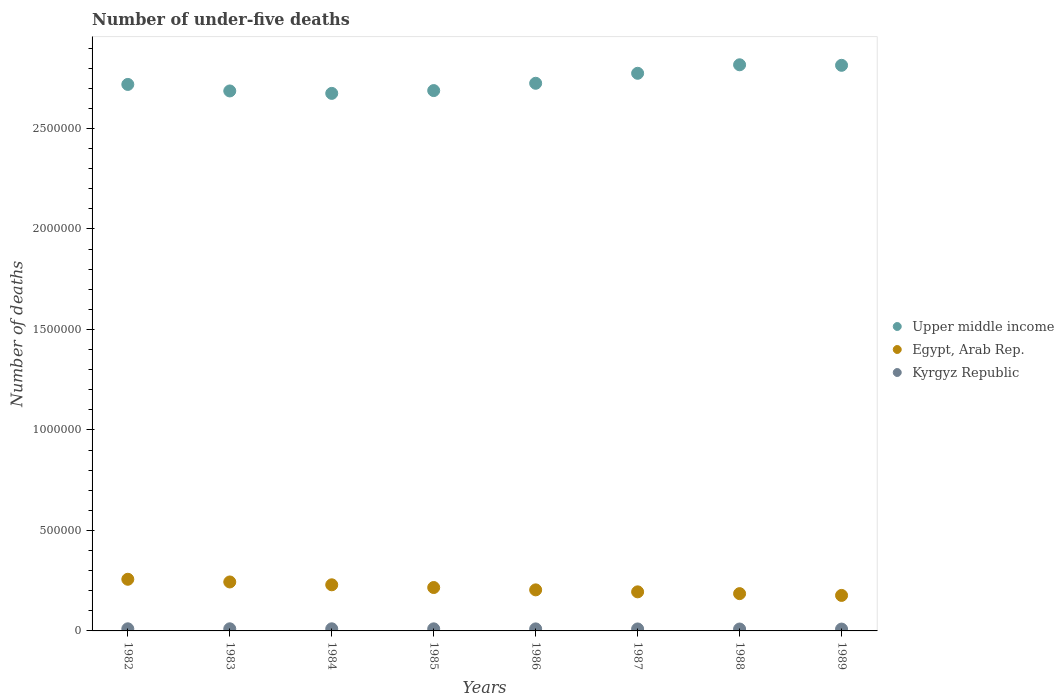How many different coloured dotlines are there?
Make the answer very short. 3. What is the number of under-five deaths in Upper middle income in 1989?
Give a very brief answer. 2.81e+06. Across all years, what is the maximum number of under-five deaths in Kyrgyz Republic?
Your response must be concise. 1.05e+04. Across all years, what is the minimum number of under-five deaths in Egypt, Arab Rep.?
Your answer should be compact. 1.77e+05. In which year was the number of under-five deaths in Egypt, Arab Rep. minimum?
Provide a short and direct response. 1989. What is the total number of under-five deaths in Kyrgyz Republic in the graph?
Keep it short and to the point. 8.05e+04. What is the difference between the number of under-five deaths in Kyrgyz Republic in 1982 and that in 1985?
Give a very brief answer. 172. What is the difference between the number of under-five deaths in Kyrgyz Republic in 1984 and the number of under-five deaths in Egypt, Arab Rep. in 1986?
Give a very brief answer. -1.94e+05. What is the average number of under-five deaths in Upper middle income per year?
Your answer should be compact. 2.74e+06. In the year 1986, what is the difference between the number of under-five deaths in Upper middle income and number of under-five deaths in Kyrgyz Republic?
Give a very brief answer. 2.71e+06. In how many years, is the number of under-five deaths in Kyrgyz Republic greater than 1000000?
Your answer should be compact. 0. What is the ratio of the number of under-five deaths in Egypt, Arab Rep. in 1983 to that in 1986?
Offer a very short reply. 1.19. Is the number of under-five deaths in Egypt, Arab Rep. in 1986 less than that in 1989?
Ensure brevity in your answer.  No. Is the difference between the number of under-five deaths in Upper middle income in 1984 and 1986 greater than the difference between the number of under-five deaths in Kyrgyz Republic in 1984 and 1986?
Your response must be concise. No. What is the difference between the highest and the second highest number of under-five deaths in Upper middle income?
Ensure brevity in your answer.  2616. What is the difference between the highest and the lowest number of under-five deaths in Kyrgyz Republic?
Your answer should be compact. 1376. In how many years, is the number of under-five deaths in Upper middle income greater than the average number of under-five deaths in Upper middle income taken over all years?
Keep it short and to the point. 3. Is the sum of the number of under-five deaths in Egypt, Arab Rep. in 1985 and 1988 greater than the maximum number of under-five deaths in Kyrgyz Republic across all years?
Make the answer very short. Yes. Is it the case that in every year, the sum of the number of under-five deaths in Upper middle income and number of under-five deaths in Kyrgyz Republic  is greater than the number of under-five deaths in Egypt, Arab Rep.?
Offer a terse response. Yes. Is the number of under-five deaths in Upper middle income strictly greater than the number of under-five deaths in Egypt, Arab Rep. over the years?
Give a very brief answer. Yes. What is the difference between two consecutive major ticks on the Y-axis?
Make the answer very short. 5.00e+05. Are the values on the major ticks of Y-axis written in scientific E-notation?
Make the answer very short. No. Does the graph contain any zero values?
Keep it short and to the point. No. Where does the legend appear in the graph?
Your answer should be very brief. Center right. How many legend labels are there?
Offer a very short reply. 3. What is the title of the graph?
Ensure brevity in your answer.  Number of under-five deaths. Does "Albania" appear as one of the legend labels in the graph?
Make the answer very short. No. What is the label or title of the X-axis?
Offer a very short reply. Years. What is the label or title of the Y-axis?
Keep it short and to the point. Number of deaths. What is the Number of deaths of Upper middle income in 1982?
Your response must be concise. 2.72e+06. What is the Number of deaths in Egypt, Arab Rep. in 1982?
Keep it short and to the point. 2.57e+05. What is the Number of deaths of Kyrgyz Republic in 1982?
Give a very brief answer. 1.05e+04. What is the Number of deaths in Upper middle income in 1983?
Give a very brief answer. 2.69e+06. What is the Number of deaths in Egypt, Arab Rep. in 1983?
Make the answer very short. 2.44e+05. What is the Number of deaths in Kyrgyz Republic in 1983?
Your answer should be very brief. 1.05e+04. What is the Number of deaths in Upper middle income in 1984?
Your answer should be very brief. 2.67e+06. What is the Number of deaths in Egypt, Arab Rep. in 1984?
Keep it short and to the point. 2.29e+05. What is the Number of deaths of Kyrgyz Republic in 1984?
Give a very brief answer. 1.05e+04. What is the Number of deaths of Upper middle income in 1985?
Your response must be concise. 2.69e+06. What is the Number of deaths of Egypt, Arab Rep. in 1985?
Provide a short and direct response. 2.16e+05. What is the Number of deaths in Kyrgyz Republic in 1985?
Offer a terse response. 1.03e+04. What is the Number of deaths of Upper middle income in 1986?
Offer a terse response. 2.72e+06. What is the Number of deaths of Egypt, Arab Rep. in 1986?
Provide a short and direct response. 2.04e+05. What is the Number of deaths in Kyrgyz Republic in 1986?
Your answer should be very brief. 1.01e+04. What is the Number of deaths of Upper middle income in 1987?
Give a very brief answer. 2.77e+06. What is the Number of deaths of Egypt, Arab Rep. in 1987?
Your answer should be compact. 1.94e+05. What is the Number of deaths of Kyrgyz Republic in 1987?
Your response must be concise. 9800. What is the Number of deaths of Upper middle income in 1988?
Provide a succinct answer. 2.82e+06. What is the Number of deaths of Egypt, Arab Rep. in 1988?
Make the answer very short. 1.86e+05. What is the Number of deaths of Kyrgyz Republic in 1988?
Ensure brevity in your answer.  9481. What is the Number of deaths of Upper middle income in 1989?
Offer a terse response. 2.81e+06. What is the Number of deaths of Egypt, Arab Rep. in 1989?
Give a very brief answer. 1.77e+05. What is the Number of deaths in Kyrgyz Republic in 1989?
Provide a short and direct response. 9173. Across all years, what is the maximum Number of deaths in Upper middle income?
Provide a short and direct response. 2.82e+06. Across all years, what is the maximum Number of deaths of Egypt, Arab Rep.?
Provide a succinct answer. 2.57e+05. Across all years, what is the maximum Number of deaths of Kyrgyz Republic?
Keep it short and to the point. 1.05e+04. Across all years, what is the minimum Number of deaths of Upper middle income?
Make the answer very short. 2.67e+06. Across all years, what is the minimum Number of deaths of Egypt, Arab Rep.?
Keep it short and to the point. 1.77e+05. Across all years, what is the minimum Number of deaths in Kyrgyz Republic?
Your response must be concise. 9173. What is the total Number of deaths in Upper middle income in the graph?
Offer a very short reply. 2.19e+07. What is the total Number of deaths in Egypt, Arab Rep. in the graph?
Keep it short and to the point. 1.71e+06. What is the total Number of deaths of Kyrgyz Republic in the graph?
Your answer should be compact. 8.05e+04. What is the difference between the Number of deaths in Upper middle income in 1982 and that in 1983?
Your answer should be very brief. 3.25e+04. What is the difference between the Number of deaths in Egypt, Arab Rep. in 1982 and that in 1983?
Make the answer very short. 1.34e+04. What is the difference between the Number of deaths in Kyrgyz Republic in 1982 and that in 1983?
Your answer should be very brief. -41. What is the difference between the Number of deaths in Upper middle income in 1982 and that in 1984?
Ensure brevity in your answer.  4.45e+04. What is the difference between the Number of deaths of Egypt, Arab Rep. in 1982 and that in 1984?
Your answer should be very brief. 2.75e+04. What is the difference between the Number of deaths in Upper middle income in 1982 and that in 1985?
Provide a short and direct response. 3.06e+04. What is the difference between the Number of deaths of Egypt, Arab Rep. in 1982 and that in 1985?
Offer a very short reply. 4.11e+04. What is the difference between the Number of deaths of Kyrgyz Republic in 1982 and that in 1985?
Your response must be concise. 172. What is the difference between the Number of deaths in Upper middle income in 1982 and that in 1986?
Offer a terse response. -5718. What is the difference between the Number of deaths in Egypt, Arab Rep. in 1982 and that in 1986?
Ensure brevity in your answer.  5.27e+04. What is the difference between the Number of deaths in Kyrgyz Republic in 1982 and that in 1986?
Provide a short and direct response. 415. What is the difference between the Number of deaths of Upper middle income in 1982 and that in 1987?
Keep it short and to the point. -5.54e+04. What is the difference between the Number of deaths of Egypt, Arab Rep. in 1982 and that in 1987?
Keep it short and to the point. 6.26e+04. What is the difference between the Number of deaths in Kyrgyz Republic in 1982 and that in 1987?
Give a very brief answer. 708. What is the difference between the Number of deaths of Upper middle income in 1982 and that in 1988?
Provide a succinct answer. -9.77e+04. What is the difference between the Number of deaths of Egypt, Arab Rep. in 1982 and that in 1988?
Make the answer very short. 7.15e+04. What is the difference between the Number of deaths of Kyrgyz Republic in 1982 and that in 1988?
Your answer should be very brief. 1027. What is the difference between the Number of deaths in Upper middle income in 1982 and that in 1989?
Your response must be concise. -9.51e+04. What is the difference between the Number of deaths in Egypt, Arab Rep. in 1982 and that in 1989?
Ensure brevity in your answer.  8.03e+04. What is the difference between the Number of deaths in Kyrgyz Republic in 1982 and that in 1989?
Make the answer very short. 1335. What is the difference between the Number of deaths of Upper middle income in 1983 and that in 1984?
Offer a very short reply. 1.21e+04. What is the difference between the Number of deaths in Egypt, Arab Rep. in 1983 and that in 1984?
Keep it short and to the point. 1.42e+04. What is the difference between the Number of deaths of Upper middle income in 1983 and that in 1985?
Make the answer very short. -1835. What is the difference between the Number of deaths in Egypt, Arab Rep. in 1983 and that in 1985?
Make the answer very short. 2.77e+04. What is the difference between the Number of deaths of Kyrgyz Republic in 1983 and that in 1985?
Your answer should be very brief. 213. What is the difference between the Number of deaths of Upper middle income in 1983 and that in 1986?
Provide a short and direct response. -3.82e+04. What is the difference between the Number of deaths in Egypt, Arab Rep. in 1983 and that in 1986?
Keep it short and to the point. 3.93e+04. What is the difference between the Number of deaths in Kyrgyz Republic in 1983 and that in 1986?
Keep it short and to the point. 456. What is the difference between the Number of deaths in Upper middle income in 1983 and that in 1987?
Your answer should be compact. -8.79e+04. What is the difference between the Number of deaths of Egypt, Arab Rep. in 1983 and that in 1987?
Offer a terse response. 4.92e+04. What is the difference between the Number of deaths in Kyrgyz Republic in 1983 and that in 1987?
Provide a succinct answer. 749. What is the difference between the Number of deaths of Upper middle income in 1983 and that in 1988?
Keep it short and to the point. -1.30e+05. What is the difference between the Number of deaths in Egypt, Arab Rep. in 1983 and that in 1988?
Offer a very short reply. 5.81e+04. What is the difference between the Number of deaths of Kyrgyz Republic in 1983 and that in 1988?
Offer a terse response. 1068. What is the difference between the Number of deaths of Upper middle income in 1983 and that in 1989?
Offer a very short reply. -1.28e+05. What is the difference between the Number of deaths in Egypt, Arab Rep. in 1983 and that in 1989?
Ensure brevity in your answer.  6.69e+04. What is the difference between the Number of deaths in Kyrgyz Republic in 1983 and that in 1989?
Offer a very short reply. 1376. What is the difference between the Number of deaths in Upper middle income in 1984 and that in 1985?
Make the answer very short. -1.39e+04. What is the difference between the Number of deaths of Egypt, Arab Rep. in 1984 and that in 1985?
Give a very brief answer. 1.36e+04. What is the difference between the Number of deaths in Kyrgyz Republic in 1984 and that in 1985?
Your answer should be compact. 177. What is the difference between the Number of deaths of Upper middle income in 1984 and that in 1986?
Give a very brief answer. -5.03e+04. What is the difference between the Number of deaths in Egypt, Arab Rep. in 1984 and that in 1986?
Give a very brief answer. 2.52e+04. What is the difference between the Number of deaths in Kyrgyz Republic in 1984 and that in 1986?
Provide a succinct answer. 420. What is the difference between the Number of deaths in Upper middle income in 1984 and that in 1987?
Provide a succinct answer. -9.99e+04. What is the difference between the Number of deaths in Egypt, Arab Rep. in 1984 and that in 1987?
Offer a very short reply. 3.51e+04. What is the difference between the Number of deaths of Kyrgyz Republic in 1984 and that in 1987?
Make the answer very short. 713. What is the difference between the Number of deaths of Upper middle income in 1984 and that in 1988?
Offer a terse response. -1.42e+05. What is the difference between the Number of deaths in Egypt, Arab Rep. in 1984 and that in 1988?
Your answer should be compact. 4.39e+04. What is the difference between the Number of deaths of Kyrgyz Republic in 1984 and that in 1988?
Your answer should be compact. 1032. What is the difference between the Number of deaths in Upper middle income in 1984 and that in 1989?
Give a very brief answer. -1.40e+05. What is the difference between the Number of deaths in Egypt, Arab Rep. in 1984 and that in 1989?
Give a very brief answer. 5.28e+04. What is the difference between the Number of deaths in Kyrgyz Republic in 1984 and that in 1989?
Your answer should be very brief. 1340. What is the difference between the Number of deaths of Upper middle income in 1985 and that in 1986?
Keep it short and to the point. -3.64e+04. What is the difference between the Number of deaths in Egypt, Arab Rep. in 1985 and that in 1986?
Provide a short and direct response. 1.16e+04. What is the difference between the Number of deaths in Kyrgyz Republic in 1985 and that in 1986?
Offer a terse response. 243. What is the difference between the Number of deaths in Upper middle income in 1985 and that in 1987?
Offer a terse response. -8.60e+04. What is the difference between the Number of deaths in Egypt, Arab Rep. in 1985 and that in 1987?
Make the answer very short. 2.15e+04. What is the difference between the Number of deaths of Kyrgyz Republic in 1985 and that in 1987?
Provide a succinct answer. 536. What is the difference between the Number of deaths in Upper middle income in 1985 and that in 1988?
Your answer should be very brief. -1.28e+05. What is the difference between the Number of deaths of Egypt, Arab Rep. in 1985 and that in 1988?
Provide a succinct answer. 3.04e+04. What is the difference between the Number of deaths in Kyrgyz Republic in 1985 and that in 1988?
Keep it short and to the point. 855. What is the difference between the Number of deaths in Upper middle income in 1985 and that in 1989?
Give a very brief answer. -1.26e+05. What is the difference between the Number of deaths of Egypt, Arab Rep. in 1985 and that in 1989?
Provide a short and direct response. 3.92e+04. What is the difference between the Number of deaths in Kyrgyz Republic in 1985 and that in 1989?
Make the answer very short. 1163. What is the difference between the Number of deaths in Upper middle income in 1986 and that in 1987?
Ensure brevity in your answer.  -4.97e+04. What is the difference between the Number of deaths of Egypt, Arab Rep. in 1986 and that in 1987?
Offer a terse response. 9883. What is the difference between the Number of deaths in Kyrgyz Republic in 1986 and that in 1987?
Give a very brief answer. 293. What is the difference between the Number of deaths in Upper middle income in 1986 and that in 1988?
Offer a very short reply. -9.20e+04. What is the difference between the Number of deaths in Egypt, Arab Rep. in 1986 and that in 1988?
Give a very brief answer. 1.88e+04. What is the difference between the Number of deaths of Kyrgyz Republic in 1986 and that in 1988?
Your response must be concise. 612. What is the difference between the Number of deaths in Upper middle income in 1986 and that in 1989?
Offer a very short reply. -8.94e+04. What is the difference between the Number of deaths in Egypt, Arab Rep. in 1986 and that in 1989?
Your response must be concise. 2.76e+04. What is the difference between the Number of deaths in Kyrgyz Republic in 1986 and that in 1989?
Provide a short and direct response. 920. What is the difference between the Number of deaths of Upper middle income in 1987 and that in 1988?
Your answer should be compact. -4.23e+04. What is the difference between the Number of deaths of Egypt, Arab Rep. in 1987 and that in 1988?
Keep it short and to the point. 8878. What is the difference between the Number of deaths of Kyrgyz Republic in 1987 and that in 1988?
Give a very brief answer. 319. What is the difference between the Number of deaths of Upper middle income in 1987 and that in 1989?
Your answer should be very brief. -3.97e+04. What is the difference between the Number of deaths of Egypt, Arab Rep. in 1987 and that in 1989?
Ensure brevity in your answer.  1.77e+04. What is the difference between the Number of deaths of Kyrgyz Republic in 1987 and that in 1989?
Ensure brevity in your answer.  627. What is the difference between the Number of deaths in Upper middle income in 1988 and that in 1989?
Provide a succinct answer. 2616. What is the difference between the Number of deaths in Egypt, Arab Rep. in 1988 and that in 1989?
Your answer should be compact. 8860. What is the difference between the Number of deaths of Kyrgyz Republic in 1988 and that in 1989?
Your answer should be compact. 308. What is the difference between the Number of deaths of Upper middle income in 1982 and the Number of deaths of Egypt, Arab Rep. in 1983?
Provide a succinct answer. 2.48e+06. What is the difference between the Number of deaths in Upper middle income in 1982 and the Number of deaths in Kyrgyz Republic in 1983?
Offer a very short reply. 2.71e+06. What is the difference between the Number of deaths of Egypt, Arab Rep. in 1982 and the Number of deaths of Kyrgyz Republic in 1983?
Offer a very short reply. 2.46e+05. What is the difference between the Number of deaths of Upper middle income in 1982 and the Number of deaths of Egypt, Arab Rep. in 1984?
Your response must be concise. 2.49e+06. What is the difference between the Number of deaths in Upper middle income in 1982 and the Number of deaths in Kyrgyz Republic in 1984?
Your response must be concise. 2.71e+06. What is the difference between the Number of deaths in Egypt, Arab Rep. in 1982 and the Number of deaths in Kyrgyz Republic in 1984?
Offer a terse response. 2.46e+05. What is the difference between the Number of deaths of Upper middle income in 1982 and the Number of deaths of Egypt, Arab Rep. in 1985?
Provide a succinct answer. 2.50e+06. What is the difference between the Number of deaths of Upper middle income in 1982 and the Number of deaths of Kyrgyz Republic in 1985?
Your answer should be compact. 2.71e+06. What is the difference between the Number of deaths in Egypt, Arab Rep. in 1982 and the Number of deaths in Kyrgyz Republic in 1985?
Ensure brevity in your answer.  2.47e+05. What is the difference between the Number of deaths in Upper middle income in 1982 and the Number of deaths in Egypt, Arab Rep. in 1986?
Offer a very short reply. 2.51e+06. What is the difference between the Number of deaths in Upper middle income in 1982 and the Number of deaths in Kyrgyz Republic in 1986?
Your answer should be compact. 2.71e+06. What is the difference between the Number of deaths of Egypt, Arab Rep. in 1982 and the Number of deaths of Kyrgyz Republic in 1986?
Offer a terse response. 2.47e+05. What is the difference between the Number of deaths of Upper middle income in 1982 and the Number of deaths of Egypt, Arab Rep. in 1987?
Your answer should be very brief. 2.52e+06. What is the difference between the Number of deaths in Upper middle income in 1982 and the Number of deaths in Kyrgyz Republic in 1987?
Offer a terse response. 2.71e+06. What is the difference between the Number of deaths in Egypt, Arab Rep. in 1982 and the Number of deaths in Kyrgyz Republic in 1987?
Keep it short and to the point. 2.47e+05. What is the difference between the Number of deaths in Upper middle income in 1982 and the Number of deaths in Egypt, Arab Rep. in 1988?
Your response must be concise. 2.53e+06. What is the difference between the Number of deaths in Upper middle income in 1982 and the Number of deaths in Kyrgyz Republic in 1988?
Offer a terse response. 2.71e+06. What is the difference between the Number of deaths in Egypt, Arab Rep. in 1982 and the Number of deaths in Kyrgyz Republic in 1988?
Give a very brief answer. 2.48e+05. What is the difference between the Number of deaths of Upper middle income in 1982 and the Number of deaths of Egypt, Arab Rep. in 1989?
Your answer should be compact. 2.54e+06. What is the difference between the Number of deaths in Upper middle income in 1982 and the Number of deaths in Kyrgyz Republic in 1989?
Your answer should be compact. 2.71e+06. What is the difference between the Number of deaths in Egypt, Arab Rep. in 1982 and the Number of deaths in Kyrgyz Republic in 1989?
Your answer should be compact. 2.48e+05. What is the difference between the Number of deaths in Upper middle income in 1983 and the Number of deaths in Egypt, Arab Rep. in 1984?
Offer a very short reply. 2.46e+06. What is the difference between the Number of deaths of Upper middle income in 1983 and the Number of deaths of Kyrgyz Republic in 1984?
Make the answer very short. 2.68e+06. What is the difference between the Number of deaths in Egypt, Arab Rep. in 1983 and the Number of deaths in Kyrgyz Republic in 1984?
Offer a very short reply. 2.33e+05. What is the difference between the Number of deaths in Upper middle income in 1983 and the Number of deaths in Egypt, Arab Rep. in 1985?
Offer a terse response. 2.47e+06. What is the difference between the Number of deaths in Upper middle income in 1983 and the Number of deaths in Kyrgyz Republic in 1985?
Provide a succinct answer. 2.68e+06. What is the difference between the Number of deaths in Egypt, Arab Rep. in 1983 and the Number of deaths in Kyrgyz Republic in 1985?
Make the answer very short. 2.33e+05. What is the difference between the Number of deaths in Upper middle income in 1983 and the Number of deaths in Egypt, Arab Rep. in 1986?
Your response must be concise. 2.48e+06. What is the difference between the Number of deaths in Upper middle income in 1983 and the Number of deaths in Kyrgyz Republic in 1986?
Your response must be concise. 2.68e+06. What is the difference between the Number of deaths of Egypt, Arab Rep. in 1983 and the Number of deaths of Kyrgyz Republic in 1986?
Your response must be concise. 2.34e+05. What is the difference between the Number of deaths in Upper middle income in 1983 and the Number of deaths in Egypt, Arab Rep. in 1987?
Keep it short and to the point. 2.49e+06. What is the difference between the Number of deaths of Upper middle income in 1983 and the Number of deaths of Kyrgyz Republic in 1987?
Your response must be concise. 2.68e+06. What is the difference between the Number of deaths of Egypt, Arab Rep. in 1983 and the Number of deaths of Kyrgyz Republic in 1987?
Keep it short and to the point. 2.34e+05. What is the difference between the Number of deaths in Upper middle income in 1983 and the Number of deaths in Egypt, Arab Rep. in 1988?
Provide a short and direct response. 2.50e+06. What is the difference between the Number of deaths of Upper middle income in 1983 and the Number of deaths of Kyrgyz Republic in 1988?
Offer a terse response. 2.68e+06. What is the difference between the Number of deaths in Egypt, Arab Rep. in 1983 and the Number of deaths in Kyrgyz Republic in 1988?
Ensure brevity in your answer.  2.34e+05. What is the difference between the Number of deaths of Upper middle income in 1983 and the Number of deaths of Egypt, Arab Rep. in 1989?
Ensure brevity in your answer.  2.51e+06. What is the difference between the Number of deaths of Upper middle income in 1983 and the Number of deaths of Kyrgyz Republic in 1989?
Your response must be concise. 2.68e+06. What is the difference between the Number of deaths in Egypt, Arab Rep. in 1983 and the Number of deaths in Kyrgyz Republic in 1989?
Make the answer very short. 2.34e+05. What is the difference between the Number of deaths of Upper middle income in 1984 and the Number of deaths of Egypt, Arab Rep. in 1985?
Offer a terse response. 2.46e+06. What is the difference between the Number of deaths in Upper middle income in 1984 and the Number of deaths in Kyrgyz Republic in 1985?
Provide a succinct answer. 2.66e+06. What is the difference between the Number of deaths of Egypt, Arab Rep. in 1984 and the Number of deaths of Kyrgyz Republic in 1985?
Your response must be concise. 2.19e+05. What is the difference between the Number of deaths of Upper middle income in 1984 and the Number of deaths of Egypt, Arab Rep. in 1986?
Offer a very short reply. 2.47e+06. What is the difference between the Number of deaths of Upper middle income in 1984 and the Number of deaths of Kyrgyz Republic in 1986?
Offer a very short reply. 2.66e+06. What is the difference between the Number of deaths of Egypt, Arab Rep. in 1984 and the Number of deaths of Kyrgyz Republic in 1986?
Give a very brief answer. 2.19e+05. What is the difference between the Number of deaths in Upper middle income in 1984 and the Number of deaths in Egypt, Arab Rep. in 1987?
Offer a terse response. 2.48e+06. What is the difference between the Number of deaths in Upper middle income in 1984 and the Number of deaths in Kyrgyz Republic in 1987?
Offer a terse response. 2.66e+06. What is the difference between the Number of deaths of Egypt, Arab Rep. in 1984 and the Number of deaths of Kyrgyz Republic in 1987?
Provide a succinct answer. 2.20e+05. What is the difference between the Number of deaths in Upper middle income in 1984 and the Number of deaths in Egypt, Arab Rep. in 1988?
Your answer should be very brief. 2.49e+06. What is the difference between the Number of deaths in Upper middle income in 1984 and the Number of deaths in Kyrgyz Republic in 1988?
Offer a terse response. 2.66e+06. What is the difference between the Number of deaths of Egypt, Arab Rep. in 1984 and the Number of deaths of Kyrgyz Republic in 1988?
Offer a terse response. 2.20e+05. What is the difference between the Number of deaths in Upper middle income in 1984 and the Number of deaths in Egypt, Arab Rep. in 1989?
Make the answer very short. 2.50e+06. What is the difference between the Number of deaths in Upper middle income in 1984 and the Number of deaths in Kyrgyz Republic in 1989?
Provide a succinct answer. 2.67e+06. What is the difference between the Number of deaths of Egypt, Arab Rep. in 1984 and the Number of deaths of Kyrgyz Republic in 1989?
Ensure brevity in your answer.  2.20e+05. What is the difference between the Number of deaths of Upper middle income in 1985 and the Number of deaths of Egypt, Arab Rep. in 1986?
Provide a succinct answer. 2.48e+06. What is the difference between the Number of deaths in Upper middle income in 1985 and the Number of deaths in Kyrgyz Republic in 1986?
Keep it short and to the point. 2.68e+06. What is the difference between the Number of deaths in Egypt, Arab Rep. in 1985 and the Number of deaths in Kyrgyz Republic in 1986?
Ensure brevity in your answer.  2.06e+05. What is the difference between the Number of deaths of Upper middle income in 1985 and the Number of deaths of Egypt, Arab Rep. in 1987?
Ensure brevity in your answer.  2.49e+06. What is the difference between the Number of deaths of Upper middle income in 1985 and the Number of deaths of Kyrgyz Republic in 1987?
Provide a short and direct response. 2.68e+06. What is the difference between the Number of deaths of Egypt, Arab Rep. in 1985 and the Number of deaths of Kyrgyz Republic in 1987?
Make the answer very short. 2.06e+05. What is the difference between the Number of deaths of Upper middle income in 1985 and the Number of deaths of Egypt, Arab Rep. in 1988?
Offer a very short reply. 2.50e+06. What is the difference between the Number of deaths in Upper middle income in 1985 and the Number of deaths in Kyrgyz Republic in 1988?
Provide a succinct answer. 2.68e+06. What is the difference between the Number of deaths of Egypt, Arab Rep. in 1985 and the Number of deaths of Kyrgyz Republic in 1988?
Keep it short and to the point. 2.06e+05. What is the difference between the Number of deaths in Upper middle income in 1985 and the Number of deaths in Egypt, Arab Rep. in 1989?
Your response must be concise. 2.51e+06. What is the difference between the Number of deaths of Upper middle income in 1985 and the Number of deaths of Kyrgyz Republic in 1989?
Your response must be concise. 2.68e+06. What is the difference between the Number of deaths in Egypt, Arab Rep. in 1985 and the Number of deaths in Kyrgyz Republic in 1989?
Provide a short and direct response. 2.07e+05. What is the difference between the Number of deaths in Upper middle income in 1986 and the Number of deaths in Egypt, Arab Rep. in 1987?
Make the answer very short. 2.53e+06. What is the difference between the Number of deaths in Upper middle income in 1986 and the Number of deaths in Kyrgyz Republic in 1987?
Your response must be concise. 2.71e+06. What is the difference between the Number of deaths of Egypt, Arab Rep. in 1986 and the Number of deaths of Kyrgyz Republic in 1987?
Offer a very short reply. 1.94e+05. What is the difference between the Number of deaths of Upper middle income in 1986 and the Number of deaths of Egypt, Arab Rep. in 1988?
Give a very brief answer. 2.54e+06. What is the difference between the Number of deaths in Upper middle income in 1986 and the Number of deaths in Kyrgyz Republic in 1988?
Provide a short and direct response. 2.72e+06. What is the difference between the Number of deaths of Egypt, Arab Rep. in 1986 and the Number of deaths of Kyrgyz Republic in 1988?
Give a very brief answer. 1.95e+05. What is the difference between the Number of deaths in Upper middle income in 1986 and the Number of deaths in Egypt, Arab Rep. in 1989?
Offer a very short reply. 2.55e+06. What is the difference between the Number of deaths in Upper middle income in 1986 and the Number of deaths in Kyrgyz Republic in 1989?
Make the answer very short. 2.72e+06. What is the difference between the Number of deaths of Egypt, Arab Rep. in 1986 and the Number of deaths of Kyrgyz Republic in 1989?
Ensure brevity in your answer.  1.95e+05. What is the difference between the Number of deaths of Upper middle income in 1987 and the Number of deaths of Egypt, Arab Rep. in 1988?
Keep it short and to the point. 2.59e+06. What is the difference between the Number of deaths in Upper middle income in 1987 and the Number of deaths in Kyrgyz Republic in 1988?
Provide a succinct answer. 2.76e+06. What is the difference between the Number of deaths of Egypt, Arab Rep. in 1987 and the Number of deaths of Kyrgyz Republic in 1988?
Your answer should be very brief. 1.85e+05. What is the difference between the Number of deaths of Upper middle income in 1987 and the Number of deaths of Egypt, Arab Rep. in 1989?
Your response must be concise. 2.60e+06. What is the difference between the Number of deaths in Upper middle income in 1987 and the Number of deaths in Kyrgyz Republic in 1989?
Ensure brevity in your answer.  2.77e+06. What is the difference between the Number of deaths of Egypt, Arab Rep. in 1987 and the Number of deaths of Kyrgyz Republic in 1989?
Ensure brevity in your answer.  1.85e+05. What is the difference between the Number of deaths in Upper middle income in 1988 and the Number of deaths in Egypt, Arab Rep. in 1989?
Offer a terse response. 2.64e+06. What is the difference between the Number of deaths of Upper middle income in 1988 and the Number of deaths of Kyrgyz Republic in 1989?
Keep it short and to the point. 2.81e+06. What is the difference between the Number of deaths in Egypt, Arab Rep. in 1988 and the Number of deaths in Kyrgyz Republic in 1989?
Offer a very short reply. 1.76e+05. What is the average Number of deaths of Upper middle income per year?
Offer a terse response. 2.74e+06. What is the average Number of deaths in Egypt, Arab Rep. per year?
Ensure brevity in your answer.  2.13e+05. What is the average Number of deaths in Kyrgyz Republic per year?
Keep it short and to the point. 1.01e+04. In the year 1982, what is the difference between the Number of deaths in Upper middle income and Number of deaths in Egypt, Arab Rep.?
Your answer should be very brief. 2.46e+06. In the year 1982, what is the difference between the Number of deaths of Upper middle income and Number of deaths of Kyrgyz Republic?
Offer a very short reply. 2.71e+06. In the year 1982, what is the difference between the Number of deaths of Egypt, Arab Rep. and Number of deaths of Kyrgyz Republic?
Offer a very short reply. 2.46e+05. In the year 1983, what is the difference between the Number of deaths of Upper middle income and Number of deaths of Egypt, Arab Rep.?
Give a very brief answer. 2.44e+06. In the year 1983, what is the difference between the Number of deaths in Upper middle income and Number of deaths in Kyrgyz Republic?
Your response must be concise. 2.68e+06. In the year 1983, what is the difference between the Number of deaths in Egypt, Arab Rep. and Number of deaths in Kyrgyz Republic?
Your answer should be very brief. 2.33e+05. In the year 1984, what is the difference between the Number of deaths in Upper middle income and Number of deaths in Egypt, Arab Rep.?
Offer a very short reply. 2.44e+06. In the year 1984, what is the difference between the Number of deaths of Upper middle income and Number of deaths of Kyrgyz Republic?
Your answer should be very brief. 2.66e+06. In the year 1984, what is the difference between the Number of deaths in Egypt, Arab Rep. and Number of deaths in Kyrgyz Republic?
Your answer should be very brief. 2.19e+05. In the year 1985, what is the difference between the Number of deaths in Upper middle income and Number of deaths in Egypt, Arab Rep.?
Provide a succinct answer. 2.47e+06. In the year 1985, what is the difference between the Number of deaths in Upper middle income and Number of deaths in Kyrgyz Republic?
Provide a short and direct response. 2.68e+06. In the year 1985, what is the difference between the Number of deaths in Egypt, Arab Rep. and Number of deaths in Kyrgyz Republic?
Your answer should be very brief. 2.06e+05. In the year 1986, what is the difference between the Number of deaths of Upper middle income and Number of deaths of Egypt, Arab Rep.?
Offer a very short reply. 2.52e+06. In the year 1986, what is the difference between the Number of deaths in Upper middle income and Number of deaths in Kyrgyz Republic?
Offer a very short reply. 2.71e+06. In the year 1986, what is the difference between the Number of deaths of Egypt, Arab Rep. and Number of deaths of Kyrgyz Republic?
Ensure brevity in your answer.  1.94e+05. In the year 1987, what is the difference between the Number of deaths of Upper middle income and Number of deaths of Egypt, Arab Rep.?
Ensure brevity in your answer.  2.58e+06. In the year 1987, what is the difference between the Number of deaths of Upper middle income and Number of deaths of Kyrgyz Republic?
Your answer should be very brief. 2.76e+06. In the year 1987, what is the difference between the Number of deaths in Egypt, Arab Rep. and Number of deaths in Kyrgyz Republic?
Offer a very short reply. 1.85e+05. In the year 1988, what is the difference between the Number of deaths in Upper middle income and Number of deaths in Egypt, Arab Rep.?
Keep it short and to the point. 2.63e+06. In the year 1988, what is the difference between the Number of deaths in Upper middle income and Number of deaths in Kyrgyz Republic?
Provide a succinct answer. 2.81e+06. In the year 1988, what is the difference between the Number of deaths of Egypt, Arab Rep. and Number of deaths of Kyrgyz Republic?
Give a very brief answer. 1.76e+05. In the year 1989, what is the difference between the Number of deaths of Upper middle income and Number of deaths of Egypt, Arab Rep.?
Provide a succinct answer. 2.64e+06. In the year 1989, what is the difference between the Number of deaths of Upper middle income and Number of deaths of Kyrgyz Republic?
Your response must be concise. 2.80e+06. In the year 1989, what is the difference between the Number of deaths of Egypt, Arab Rep. and Number of deaths of Kyrgyz Republic?
Your answer should be compact. 1.67e+05. What is the ratio of the Number of deaths of Upper middle income in 1982 to that in 1983?
Make the answer very short. 1.01. What is the ratio of the Number of deaths in Egypt, Arab Rep. in 1982 to that in 1983?
Ensure brevity in your answer.  1.05. What is the ratio of the Number of deaths in Upper middle income in 1982 to that in 1984?
Ensure brevity in your answer.  1.02. What is the ratio of the Number of deaths of Egypt, Arab Rep. in 1982 to that in 1984?
Give a very brief answer. 1.12. What is the ratio of the Number of deaths of Upper middle income in 1982 to that in 1985?
Offer a terse response. 1.01. What is the ratio of the Number of deaths of Egypt, Arab Rep. in 1982 to that in 1985?
Give a very brief answer. 1.19. What is the ratio of the Number of deaths of Kyrgyz Republic in 1982 to that in 1985?
Your response must be concise. 1.02. What is the ratio of the Number of deaths in Egypt, Arab Rep. in 1982 to that in 1986?
Keep it short and to the point. 1.26. What is the ratio of the Number of deaths in Kyrgyz Republic in 1982 to that in 1986?
Keep it short and to the point. 1.04. What is the ratio of the Number of deaths in Egypt, Arab Rep. in 1982 to that in 1987?
Your answer should be very brief. 1.32. What is the ratio of the Number of deaths of Kyrgyz Republic in 1982 to that in 1987?
Keep it short and to the point. 1.07. What is the ratio of the Number of deaths in Upper middle income in 1982 to that in 1988?
Offer a very short reply. 0.97. What is the ratio of the Number of deaths of Egypt, Arab Rep. in 1982 to that in 1988?
Offer a terse response. 1.39. What is the ratio of the Number of deaths of Kyrgyz Republic in 1982 to that in 1988?
Ensure brevity in your answer.  1.11. What is the ratio of the Number of deaths in Upper middle income in 1982 to that in 1989?
Keep it short and to the point. 0.97. What is the ratio of the Number of deaths of Egypt, Arab Rep. in 1982 to that in 1989?
Make the answer very short. 1.45. What is the ratio of the Number of deaths in Kyrgyz Republic in 1982 to that in 1989?
Keep it short and to the point. 1.15. What is the ratio of the Number of deaths in Upper middle income in 1983 to that in 1984?
Provide a succinct answer. 1. What is the ratio of the Number of deaths in Egypt, Arab Rep. in 1983 to that in 1984?
Your answer should be compact. 1.06. What is the ratio of the Number of deaths of Kyrgyz Republic in 1983 to that in 1984?
Make the answer very short. 1. What is the ratio of the Number of deaths of Upper middle income in 1983 to that in 1985?
Offer a very short reply. 1. What is the ratio of the Number of deaths of Egypt, Arab Rep. in 1983 to that in 1985?
Ensure brevity in your answer.  1.13. What is the ratio of the Number of deaths of Kyrgyz Republic in 1983 to that in 1985?
Give a very brief answer. 1.02. What is the ratio of the Number of deaths in Upper middle income in 1983 to that in 1986?
Give a very brief answer. 0.99. What is the ratio of the Number of deaths of Egypt, Arab Rep. in 1983 to that in 1986?
Your answer should be very brief. 1.19. What is the ratio of the Number of deaths of Kyrgyz Republic in 1983 to that in 1986?
Ensure brevity in your answer.  1.05. What is the ratio of the Number of deaths in Upper middle income in 1983 to that in 1987?
Ensure brevity in your answer.  0.97. What is the ratio of the Number of deaths in Egypt, Arab Rep. in 1983 to that in 1987?
Your response must be concise. 1.25. What is the ratio of the Number of deaths in Kyrgyz Republic in 1983 to that in 1987?
Offer a terse response. 1.08. What is the ratio of the Number of deaths in Upper middle income in 1983 to that in 1988?
Your response must be concise. 0.95. What is the ratio of the Number of deaths in Egypt, Arab Rep. in 1983 to that in 1988?
Give a very brief answer. 1.31. What is the ratio of the Number of deaths of Kyrgyz Republic in 1983 to that in 1988?
Your answer should be compact. 1.11. What is the ratio of the Number of deaths of Upper middle income in 1983 to that in 1989?
Your response must be concise. 0.95. What is the ratio of the Number of deaths in Egypt, Arab Rep. in 1983 to that in 1989?
Make the answer very short. 1.38. What is the ratio of the Number of deaths in Kyrgyz Republic in 1983 to that in 1989?
Ensure brevity in your answer.  1.15. What is the ratio of the Number of deaths in Upper middle income in 1984 to that in 1985?
Offer a very short reply. 0.99. What is the ratio of the Number of deaths in Egypt, Arab Rep. in 1984 to that in 1985?
Provide a succinct answer. 1.06. What is the ratio of the Number of deaths in Kyrgyz Republic in 1984 to that in 1985?
Your response must be concise. 1.02. What is the ratio of the Number of deaths in Upper middle income in 1984 to that in 1986?
Offer a terse response. 0.98. What is the ratio of the Number of deaths of Egypt, Arab Rep. in 1984 to that in 1986?
Provide a short and direct response. 1.12. What is the ratio of the Number of deaths of Kyrgyz Republic in 1984 to that in 1986?
Provide a short and direct response. 1.04. What is the ratio of the Number of deaths of Egypt, Arab Rep. in 1984 to that in 1987?
Your answer should be compact. 1.18. What is the ratio of the Number of deaths in Kyrgyz Republic in 1984 to that in 1987?
Provide a succinct answer. 1.07. What is the ratio of the Number of deaths in Upper middle income in 1984 to that in 1988?
Offer a very short reply. 0.95. What is the ratio of the Number of deaths in Egypt, Arab Rep. in 1984 to that in 1988?
Give a very brief answer. 1.24. What is the ratio of the Number of deaths in Kyrgyz Republic in 1984 to that in 1988?
Ensure brevity in your answer.  1.11. What is the ratio of the Number of deaths in Upper middle income in 1984 to that in 1989?
Your response must be concise. 0.95. What is the ratio of the Number of deaths of Egypt, Arab Rep. in 1984 to that in 1989?
Offer a very short reply. 1.3. What is the ratio of the Number of deaths of Kyrgyz Republic in 1984 to that in 1989?
Provide a short and direct response. 1.15. What is the ratio of the Number of deaths in Upper middle income in 1985 to that in 1986?
Provide a succinct answer. 0.99. What is the ratio of the Number of deaths of Egypt, Arab Rep. in 1985 to that in 1986?
Keep it short and to the point. 1.06. What is the ratio of the Number of deaths in Kyrgyz Republic in 1985 to that in 1986?
Offer a very short reply. 1.02. What is the ratio of the Number of deaths in Egypt, Arab Rep. in 1985 to that in 1987?
Ensure brevity in your answer.  1.11. What is the ratio of the Number of deaths in Kyrgyz Republic in 1985 to that in 1987?
Ensure brevity in your answer.  1.05. What is the ratio of the Number of deaths in Upper middle income in 1985 to that in 1988?
Provide a succinct answer. 0.95. What is the ratio of the Number of deaths of Egypt, Arab Rep. in 1985 to that in 1988?
Offer a terse response. 1.16. What is the ratio of the Number of deaths in Kyrgyz Republic in 1985 to that in 1988?
Provide a short and direct response. 1.09. What is the ratio of the Number of deaths of Upper middle income in 1985 to that in 1989?
Your answer should be very brief. 0.96. What is the ratio of the Number of deaths of Egypt, Arab Rep. in 1985 to that in 1989?
Offer a terse response. 1.22. What is the ratio of the Number of deaths in Kyrgyz Republic in 1985 to that in 1989?
Your answer should be very brief. 1.13. What is the ratio of the Number of deaths of Upper middle income in 1986 to that in 1987?
Offer a very short reply. 0.98. What is the ratio of the Number of deaths of Egypt, Arab Rep. in 1986 to that in 1987?
Your answer should be compact. 1.05. What is the ratio of the Number of deaths in Kyrgyz Republic in 1986 to that in 1987?
Make the answer very short. 1.03. What is the ratio of the Number of deaths in Upper middle income in 1986 to that in 1988?
Provide a succinct answer. 0.97. What is the ratio of the Number of deaths of Egypt, Arab Rep. in 1986 to that in 1988?
Provide a succinct answer. 1.1. What is the ratio of the Number of deaths of Kyrgyz Republic in 1986 to that in 1988?
Offer a terse response. 1.06. What is the ratio of the Number of deaths in Upper middle income in 1986 to that in 1989?
Make the answer very short. 0.97. What is the ratio of the Number of deaths of Egypt, Arab Rep. in 1986 to that in 1989?
Offer a terse response. 1.16. What is the ratio of the Number of deaths of Kyrgyz Republic in 1986 to that in 1989?
Give a very brief answer. 1.1. What is the ratio of the Number of deaths in Upper middle income in 1987 to that in 1988?
Keep it short and to the point. 0.98. What is the ratio of the Number of deaths of Egypt, Arab Rep. in 1987 to that in 1988?
Offer a very short reply. 1.05. What is the ratio of the Number of deaths of Kyrgyz Republic in 1987 to that in 1988?
Keep it short and to the point. 1.03. What is the ratio of the Number of deaths in Upper middle income in 1987 to that in 1989?
Give a very brief answer. 0.99. What is the ratio of the Number of deaths of Egypt, Arab Rep. in 1987 to that in 1989?
Offer a very short reply. 1.1. What is the ratio of the Number of deaths of Kyrgyz Republic in 1987 to that in 1989?
Keep it short and to the point. 1.07. What is the ratio of the Number of deaths in Egypt, Arab Rep. in 1988 to that in 1989?
Your response must be concise. 1.05. What is the ratio of the Number of deaths of Kyrgyz Republic in 1988 to that in 1989?
Offer a terse response. 1.03. What is the difference between the highest and the second highest Number of deaths of Upper middle income?
Your answer should be very brief. 2616. What is the difference between the highest and the second highest Number of deaths of Egypt, Arab Rep.?
Your answer should be compact. 1.34e+04. What is the difference between the highest and the second highest Number of deaths in Kyrgyz Republic?
Your response must be concise. 36. What is the difference between the highest and the lowest Number of deaths in Upper middle income?
Offer a very short reply. 1.42e+05. What is the difference between the highest and the lowest Number of deaths in Egypt, Arab Rep.?
Provide a short and direct response. 8.03e+04. What is the difference between the highest and the lowest Number of deaths of Kyrgyz Republic?
Provide a short and direct response. 1376. 